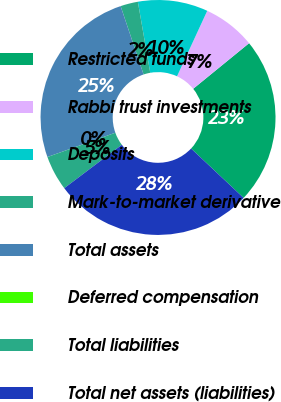Convert chart. <chart><loc_0><loc_0><loc_500><loc_500><pie_chart><fcel>Restricted funds<fcel>Rabbi trust investments<fcel>Deposits<fcel>Mark-to-market derivative<fcel>Total assets<fcel>Deferred compensation<fcel>Total liabilities<fcel>Total net assets (liabilities)<nl><fcel>22.9%<fcel>7.23%<fcel>9.63%<fcel>2.41%<fcel>25.31%<fcel>0.0%<fcel>4.82%<fcel>27.71%<nl></chart> 